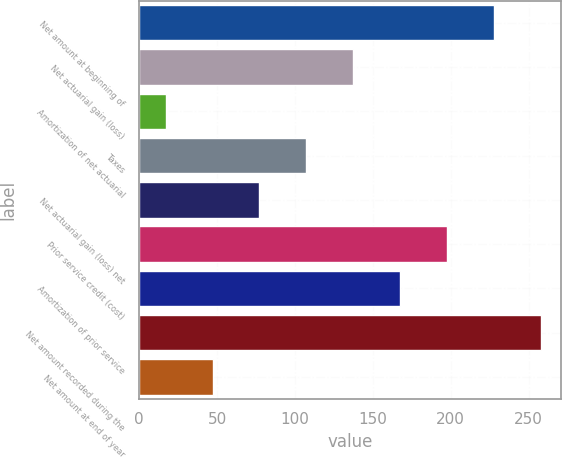Convert chart to OTSL. <chart><loc_0><loc_0><loc_500><loc_500><bar_chart><fcel>Net amount at beginning of<fcel>Net actuarial gain (loss)<fcel>Amortization of net actuarial<fcel>Taxes<fcel>Net actuarial gain (loss) net<fcel>Prior service credit (cost)<fcel>Amortization of prior service<fcel>Net amount recorded during the<fcel>Net amount at end of year<nl><fcel>227.7<fcel>137.4<fcel>17<fcel>107.3<fcel>77.2<fcel>197.6<fcel>167.5<fcel>257.8<fcel>47.1<nl></chart> 